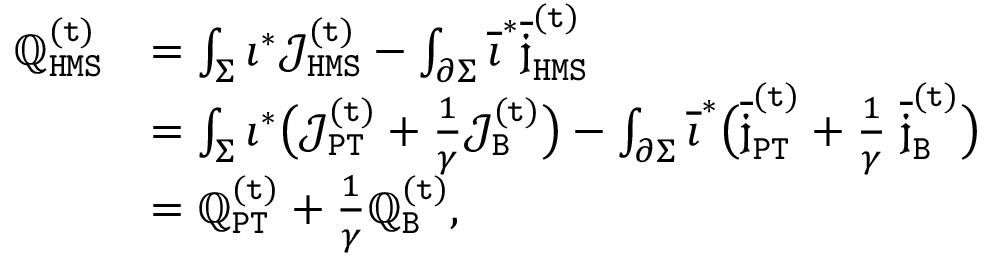Convert formula to latex. <formula><loc_0><loc_0><loc_500><loc_500>\begin{array} { r l } { \mathbb { Q } _ { H M S } ^ { ( t ) } } & { = \int _ { \Sigma } \imath ^ { * } \mathcal { J } _ { H M S } ^ { ( t ) } - \int _ { \partial \Sigma } \overline { \imath } ^ { * } \overline { { \mathfrak { j } } } _ { H M S } ^ { ( t ) } } \\ & { = \int _ { \Sigma } \imath ^ { * } \left ( \mathcal { J } _ { P T } ^ { ( t ) } + \frac { 1 } { \gamma } \mathcal { J } _ { B } ^ { ( t ) } \right ) - \int _ { \partial \Sigma } \overline { \imath } ^ { * } \left ( \overline { { \mathfrak { j } } } _ { P T } ^ { ( t ) } + \frac { 1 } { \gamma } \, \overline { { \mathfrak { j } } } _ { B } ^ { ( t ) } \right ) } \\ & { = \mathbb { Q } _ { P T } ^ { ( t ) } + \frac { 1 } { \gamma } \mathbb { Q } _ { B } ^ { ( t ) } , } \end{array}</formula> 